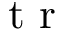Convert formula to latex. <formula><loc_0><loc_0><loc_500><loc_500>t r</formula> 